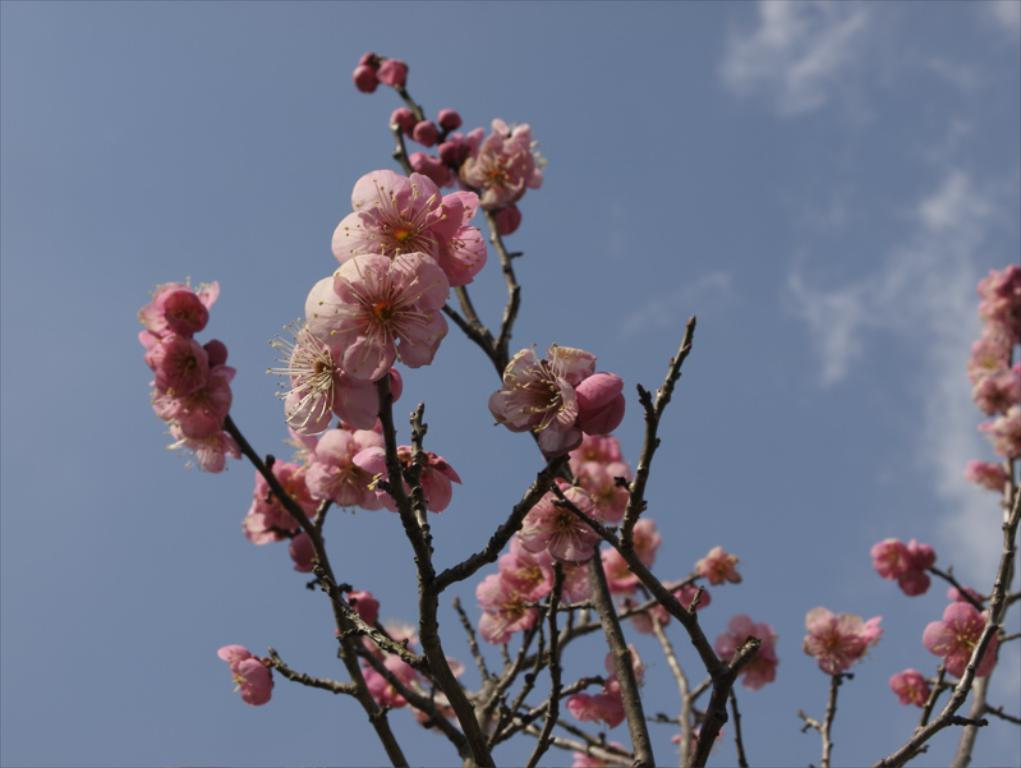What type of vegetation can be seen on the tree in the image? There are: There are flowers on a tree in the image. What is visible in the background of the image? The sky is visible in the image. What type of memory is stored in the flowers in the image? There is no indication in the image that the flowers have any memory, as flowers are not capable of storing memories. 